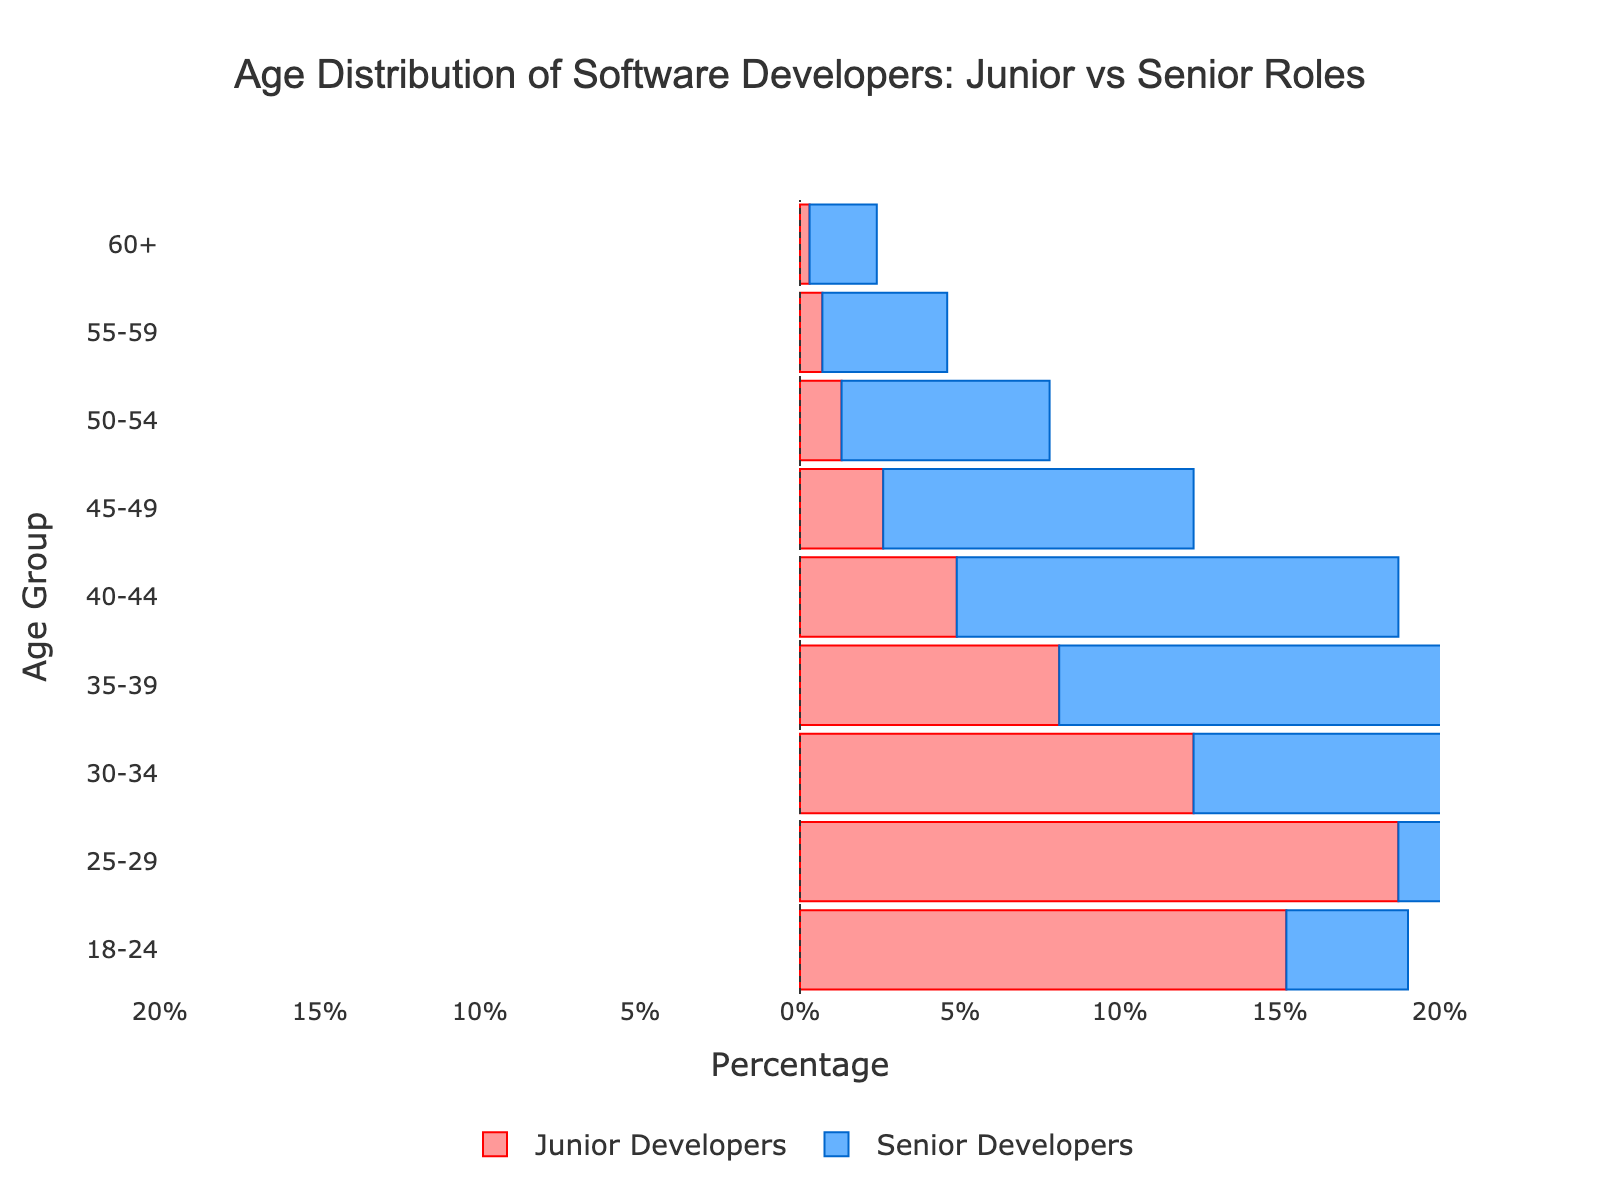What is the percentage of junior developers aged 25-29? Look at the bar corresponding to the age group 25-29, and check the length of the bar for the junior developers side, which shows 18.7%.
Answer: 18.7% What is the difference in the percentage between senior and junior developers aged 30-34? Check the bar lengths for both junior (12.3%) and senior developers (14.6%) in the age group 30-34. The difference in the percentage is calculated as 14.6% - 12.3% = 2.3%.
Answer: 2.3% Which age group has the highest percentage of senior developers? Compare the lengths of all bars representing senior developers across different age groups. The group with the longest bar is 35-39, which is 17.2%.
Answer: 35-39 What is the combined percentage of junior and senior developers for the age group 55-59? Add the percentages for junior (0.7%) and senior (3.9%) developers in the age group 55-59. The combined percentage is 0.7% + 3.9% = 4.6%.
Answer: 4.6% Are there more junior developers aged 18-24 or senior developers aged 40-44? Compare the lengths of the bars for junior developers aged 18-24 (15.2%) and senior developers aged 40-44 (13.8%). The bar for junior developers aged 18-24 is longer.
Answer: Junior developers aged 18-24 How many age groups have more than 10% of senior developers? Observe the bars representing senior developers: 25-29, 30-34, 35-39, and 40-44. This gives us four age groups.
Answer: Four In which age group is the percentage of junior developers closest to 5%? Look at the percentages for junior developers in all age groups and find the value closest to 5%, which is the age group 45-49 (2.6%).
Answer: 45-49 For the age group 50-54, how much higher is the percentage of senior developers compared to junior developers? Identify the percentage values for both junior (1.3%) and senior (6.5%) developers in this age group. Calculate the difference: 6.5% - 1.3% = 5.2%.
Answer: 5.2% What is the overall trend in the distribution of senior developers as age increases? Observe the bars representing senior developers across age groups. The percentage increases up to age group 35-39, then gradually decreases.
Answer: Increases then decreases 